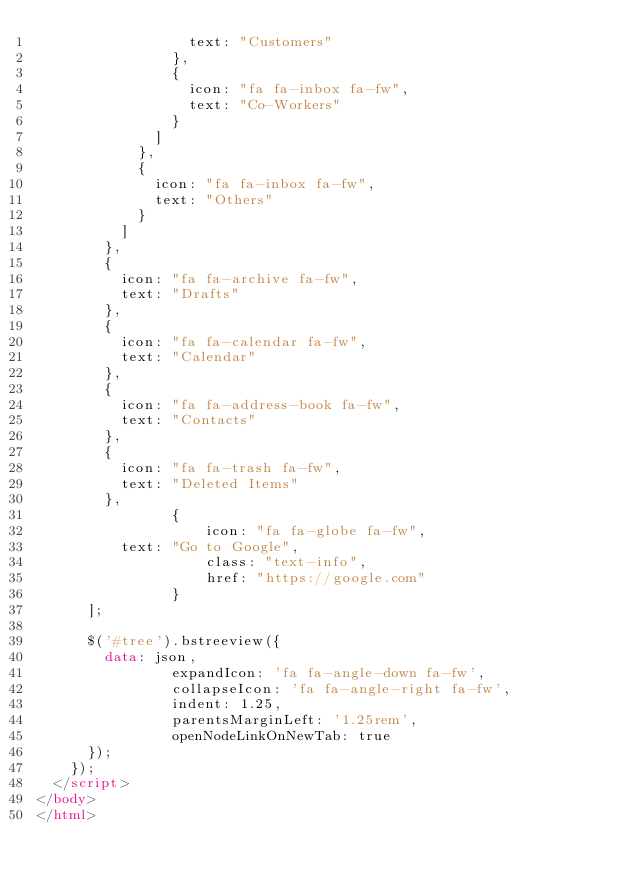Convert code to text. <code><loc_0><loc_0><loc_500><loc_500><_HTML_>									text: "Customers"
								},
								{
									icon: "fa fa-inbox fa-fw",
									text: "Co-Workers"
								}
							]
						},
						{
							icon: "fa fa-inbox fa-fw",
							text: "Others"
						}
					]
				},
				{
					icon: "fa fa-archive fa-fw",
					text: "Drafts"
				},
				{
					icon: "fa fa-calendar fa-fw",
					text: "Calendar"
				},
				{
					icon: "fa fa-address-book fa-fw",
					text: "Contacts"
				},
				{
					icon: "fa fa-trash fa-fw",
					text: "Deleted Items"
				},
                {
                    icon: "fa fa-globe fa-fw",
					text: "Go to Google",
                    class: "text-info",
                    href: "https://google.com"
                }
			];

			$('#tree').bstreeview({
				data: json,
                expandIcon: 'fa fa-angle-down fa-fw',
                collapseIcon: 'fa fa-angle-right fa-fw',
                indent: 1.25,
                parentsMarginLeft: '1.25rem',
                openNodeLinkOnNewTab: true
			});
		});
	</script>
</body>
</html>
</code> 